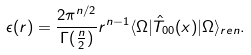Convert formula to latex. <formula><loc_0><loc_0><loc_500><loc_500>\epsilon ( r ) = \frac { 2 \pi ^ { n / 2 } } { \Gamma ( \frac { n } { 2 } ) } r ^ { n - 1 } \langle \Omega | \hat { T } _ { 0 0 } ( x ) | \Omega \rangle _ { r e n } .</formula> 